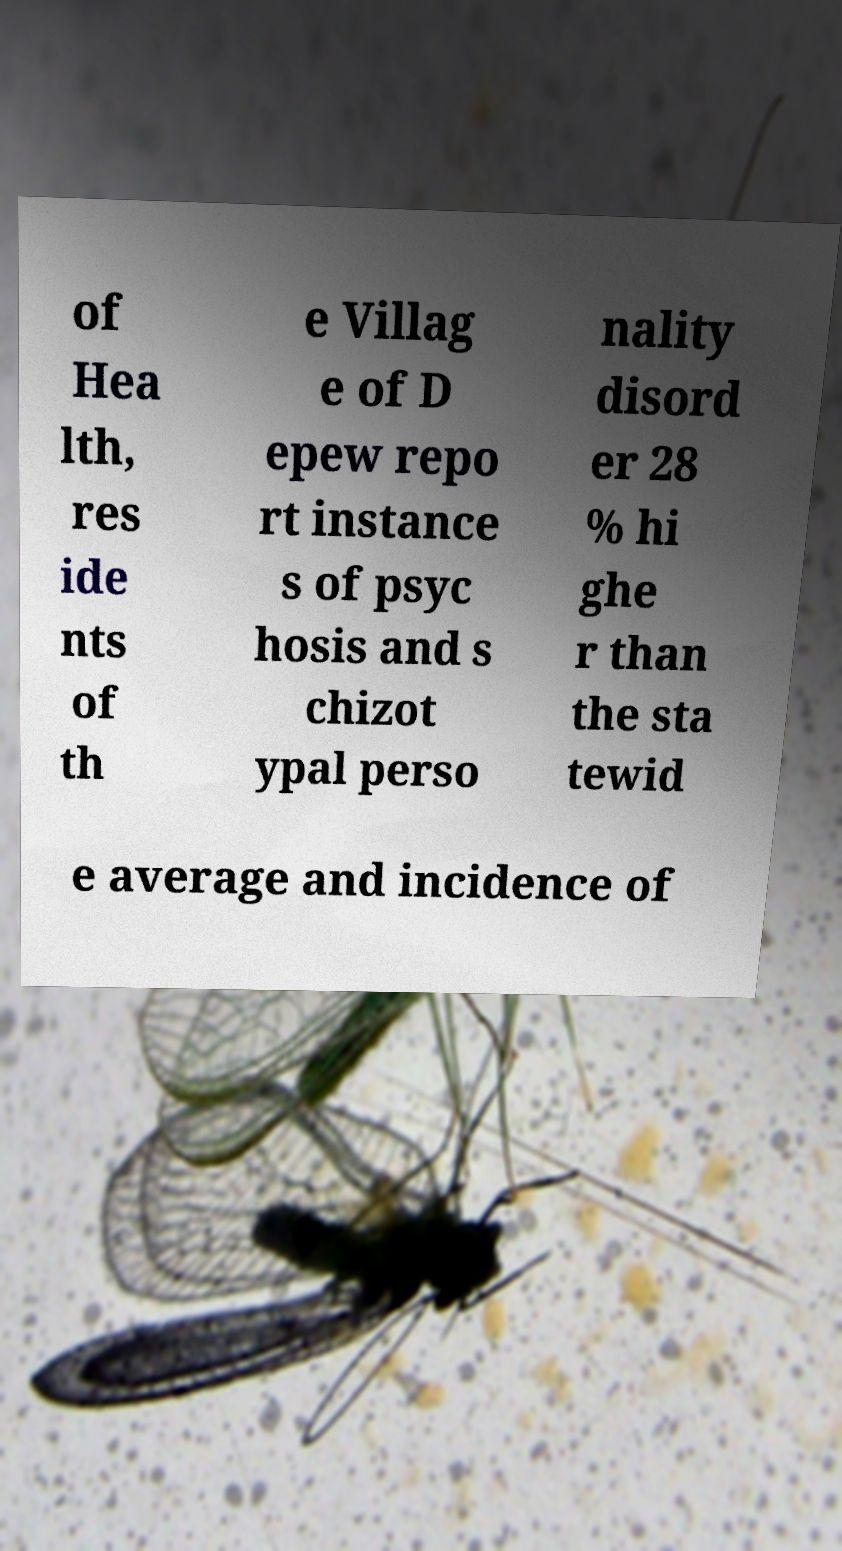What messages or text are displayed in this image? I need them in a readable, typed format. of Hea lth, res ide nts of th e Villag e of D epew repo rt instance s of psyc hosis and s chizot ypal perso nality disord er 28 % hi ghe r than the sta tewid e average and incidence of 